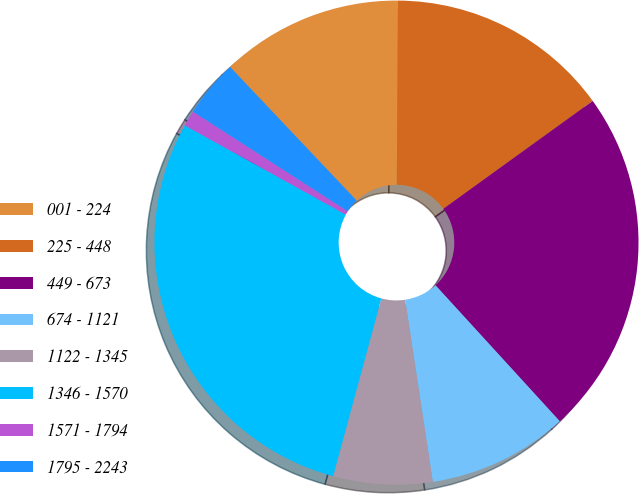Convert chart. <chart><loc_0><loc_0><loc_500><loc_500><pie_chart><fcel>001 - 224<fcel>225 - 448<fcel>449 - 673<fcel>674 - 1121<fcel>1122 - 1345<fcel>1346 - 1570<fcel>1571 - 1794<fcel>1795 - 2243<nl><fcel>12.17%<fcel>14.95%<fcel>23.17%<fcel>9.39%<fcel>6.61%<fcel>28.84%<fcel>1.05%<fcel>3.83%<nl></chart> 